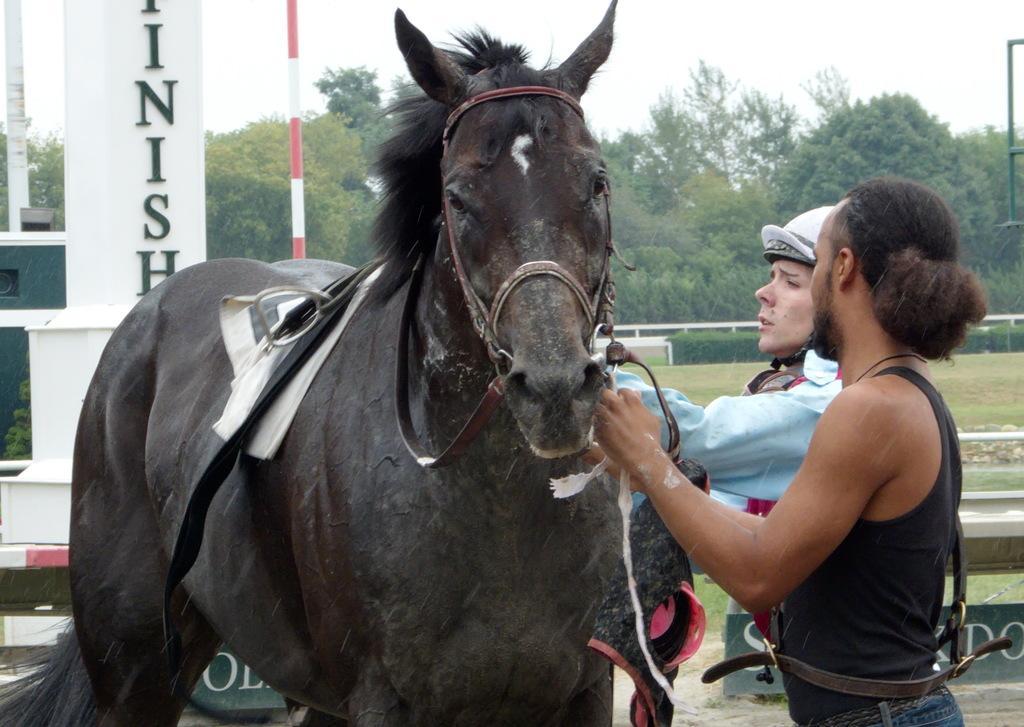Can you describe this image briefly? In this image, there is an outside view. There are two persons standing and wearing clothes. There is horse in the center of the image. There are some trees and sky at the top of the image. 